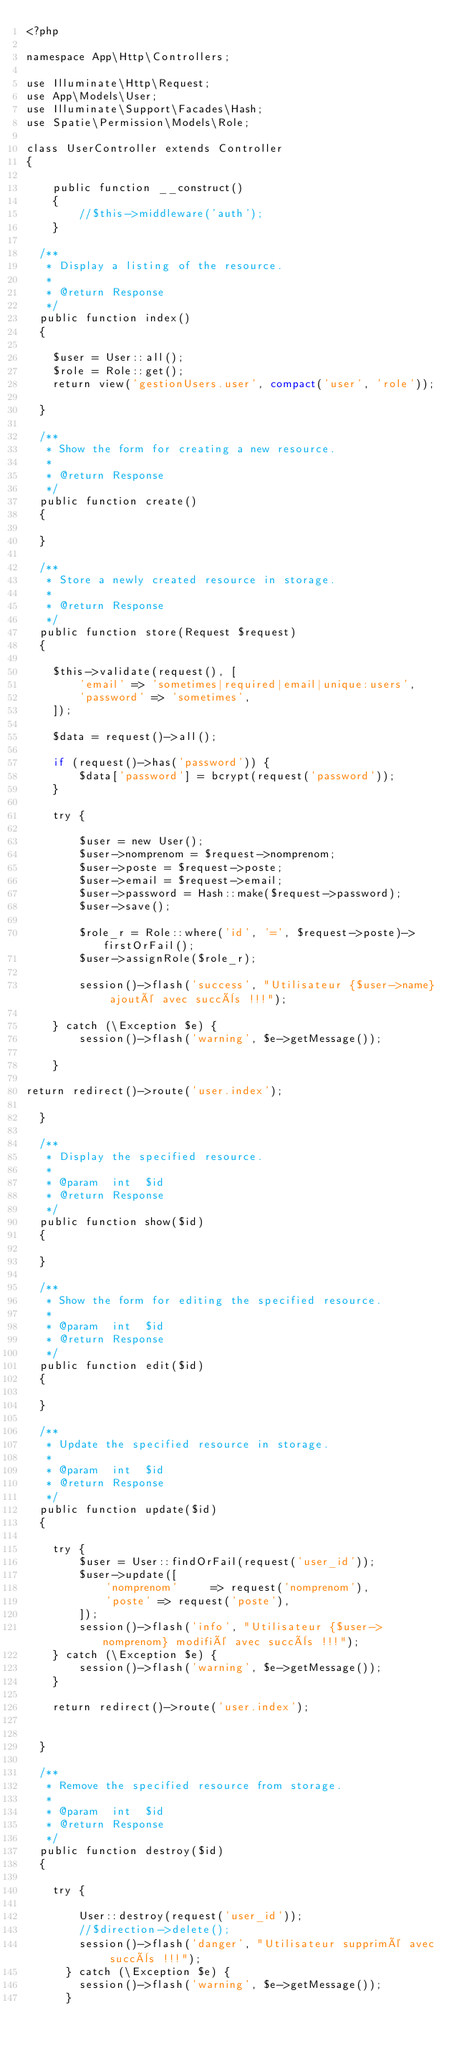<code> <loc_0><loc_0><loc_500><loc_500><_PHP_><?php

namespace App\Http\Controllers;

use Illuminate\Http\Request;
use App\Models\User;
use Illuminate\Support\Facades\Hash;
use Spatie\Permission\Models\Role;

class UserController extends Controller
{

    public function __construct()
    {
        //$this->middleware('auth');
    }

  /**
   * Display a listing of the resource.
   *
   * @return Response
   */
  public function index()
  {

    $user = User::all();
    $role = Role::get();
    return view('gestionUsers.user', compact('user', 'role'));

  }

  /**
   * Show the form for creating a new resource.
   *
   * @return Response
   */
  public function create()
  {

  }

  /**
   * Store a newly created resource in storage.
   *
   * @return Response
   */
  public function store(Request $request)
  {

    $this->validate(request(), [
        'email' => 'sometimes|required|email|unique:users',
        'password' => 'sometimes',
    ]);

    $data = request()->all();

    if (request()->has('password')) {
        $data['password'] = bcrypt(request('password'));
    }

    try {

        $user = new User();
        $user->nomprenom = $request->nomprenom;
        $user->poste = $request->poste;
        $user->email = $request->email;
        $user->password = Hash::make($request->password);
        $user->save();

        $role_r = Role::where('id', '=', $request->poste)->firstOrFail();
        $user->assignRole($role_r);

        session()->flash('success', "Utilisateur {$user->name} ajouté avec succès !!!");

    } catch (\Exception $e) {
        session()->flash('warning', $e->getMessage());

    }

return redirect()->route('user.index');

  }

  /**
   * Display the specified resource.
   *
   * @param  int  $id
   * @return Response
   */
  public function show($id)
  {

  }

  /**
   * Show the form for editing the specified resource.
   *
   * @param  int  $id
   * @return Response
   */
  public function edit($id)
  {

  }

  /**
   * Update the specified resource in storage.
   *
   * @param  int  $id
   * @return Response
   */
  public function update($id)
  {

    try {
        $user = User::findOrFail(request('user_id'));
        $user->update([
            'nomprenom'     => request('nomprenom'),
            'poste' => request('poste'),
        ]);
        session()->flash('info', "Utilisateur {$user->nomprenom} modifié avec succès !!!");
    } catch (\Exception $e) {
        session()->flash('warning', $e->getMessage());
    }

    return redirect()->route('user.index');


  }

  /**
   * Remove the specified resource from storage.
   *
   * @param  int  $id
   * @return Response
   */
  public function destroy($id)
  {

    try {

        User::destroy(request('user_id'));
        //$direction->delete();
        session()->flash('danger', "Utilisateur supprimé avec succès !!!");
      } catch (\Exception $e) {
        session()->flash('warning', $e->getMessage());
      }</code> 